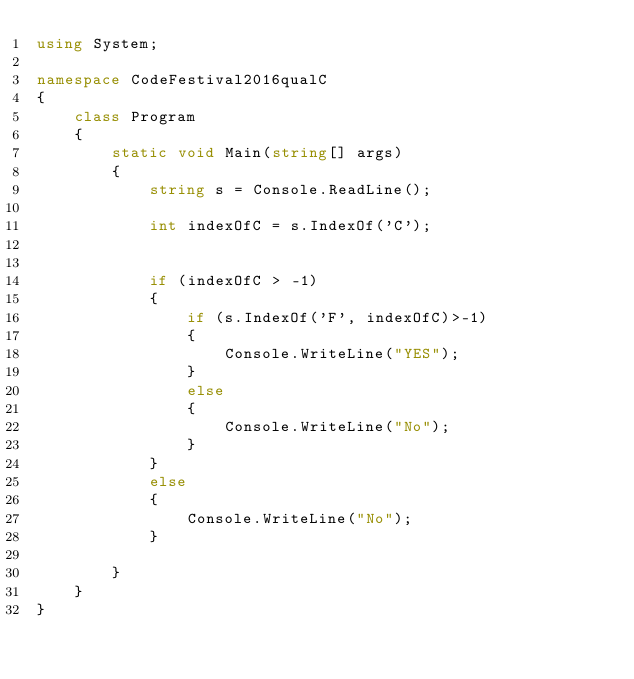<code> <loc_0><loc_0><loc_500><loc_500><_C#_>using System;

namespace CodeFestival2016qualC
{
    class Program
    {
        static void Main(string[] args)
        {
            string s = Console.ReadLine();

            int indexOfC = s.IndexOf('C');


            if (indexOfC > -1)
            {
                if (s.IndexOf('F', indexOfC)>-1)
                {
                    Console.WriteLine("YES");
                }
                else
                {
                    Console.WriteLine("No");
                }
            }
            else
            {
                Console.WriteLine("No");
            }

        }
    }
}
</code> 